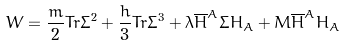Convert formula to latex. <formula><loc_0><loc_0><loc_500><loc_500>W = \frac { m } { 2 } T r \Sigma ^ { 2 } + \frac { h } { 3 } T r \Sigma ^ { 3 } + \lambda \overline { H } ^ { A } \Sigma H _ { A } + M \overline { H } ^ { A } H _ { A }</formula> 